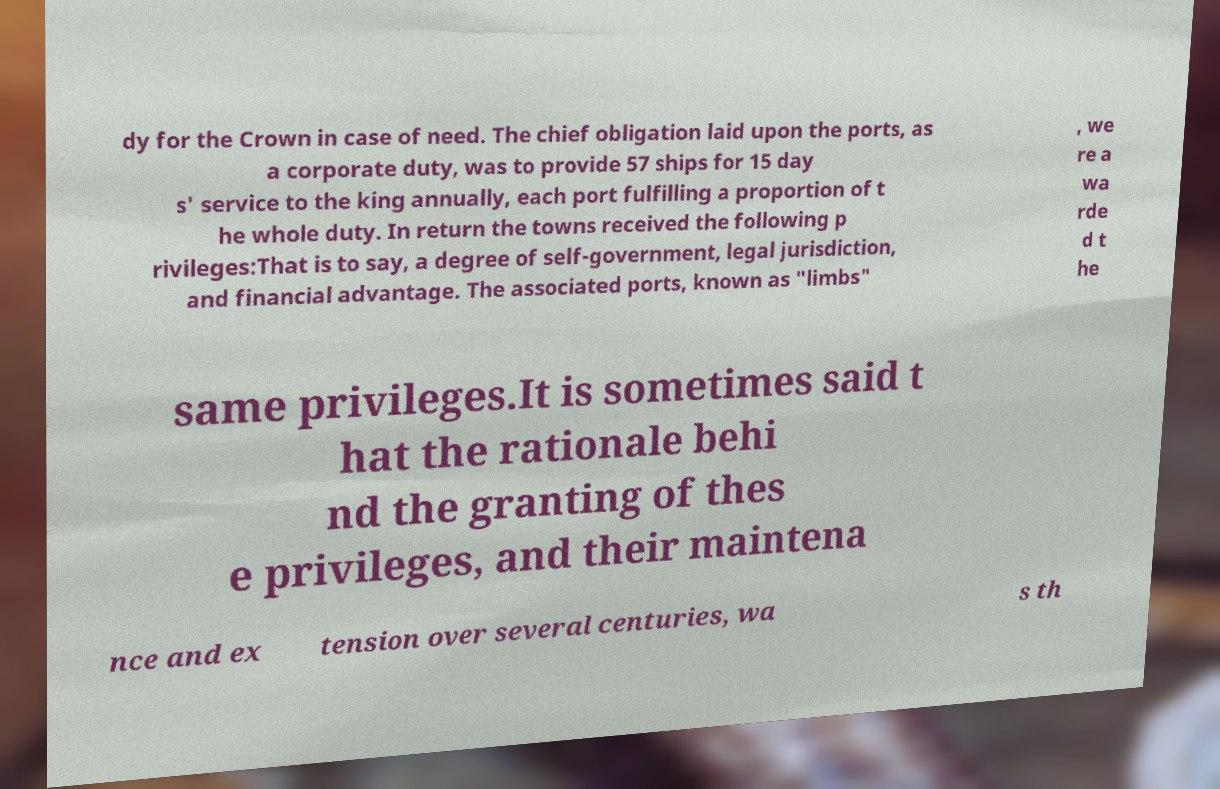For documentation purposes, I need the text within this image transcribed. Could you provide that? dy for the Crown in case of need. The chief obligation laid upon the ports, as a corporate duty, was to provide 57 ships for 15 day s' service to the king annually, each port fulfilling a proportion of t he whole duty. In return the towns received the following p rivileges:That is to say, a degree of self-government, legal jurisdiction, and financial advantage. The associated ports, known as "limbs" , we re a wa rde d t he same privileges.It is sometimes said t hat the rationale behi nd the granting of thes e privileges, and their maintena nce and ex tension over several centuries, wa s th 